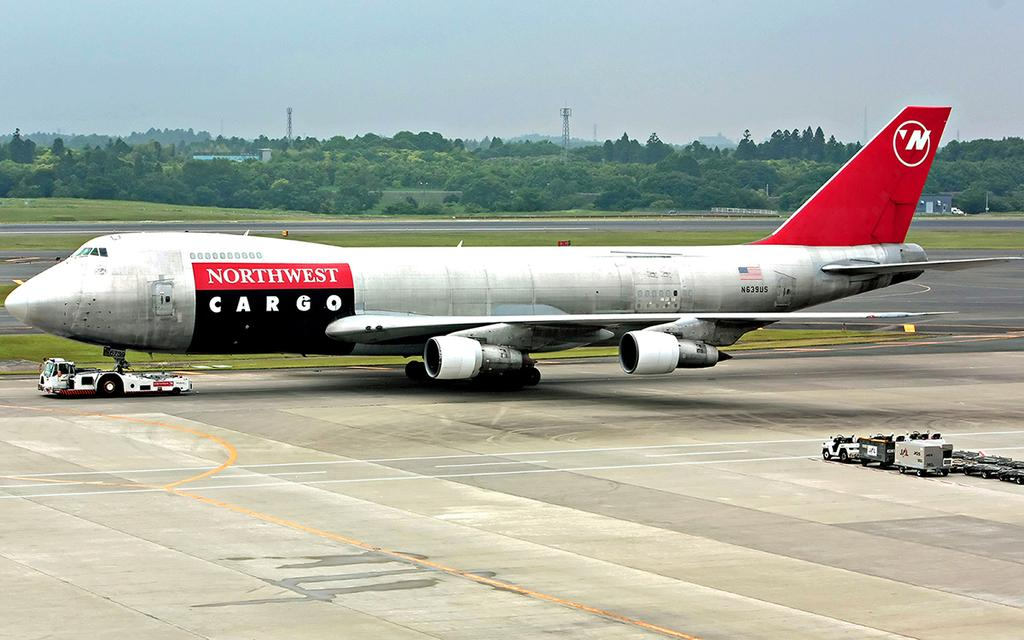<image>
Relay a brief, clear account of the picture shown. a Northwest Cargo plane is being tugged out on a runway 